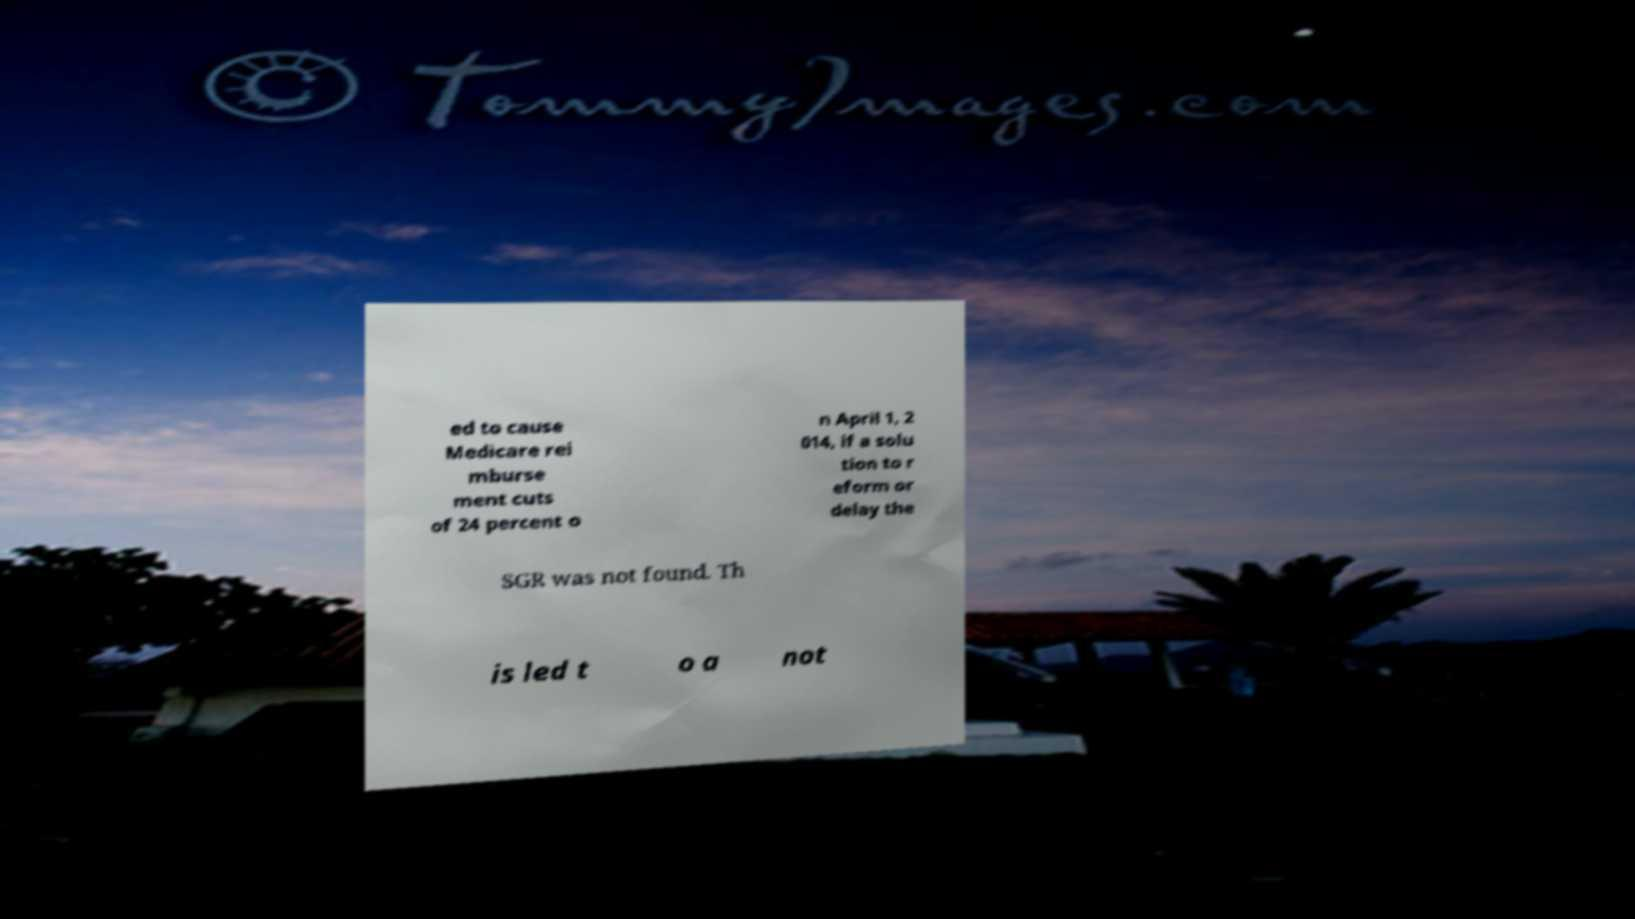What messages or text are displayed in this image? I need them in a readable, typed format. ed to cause Medicare rei mburse ment cuts of 24 percent o n April 1, 2 014, if a solu tion to r eform or delay the SGR was not found. Th is led t o a not 